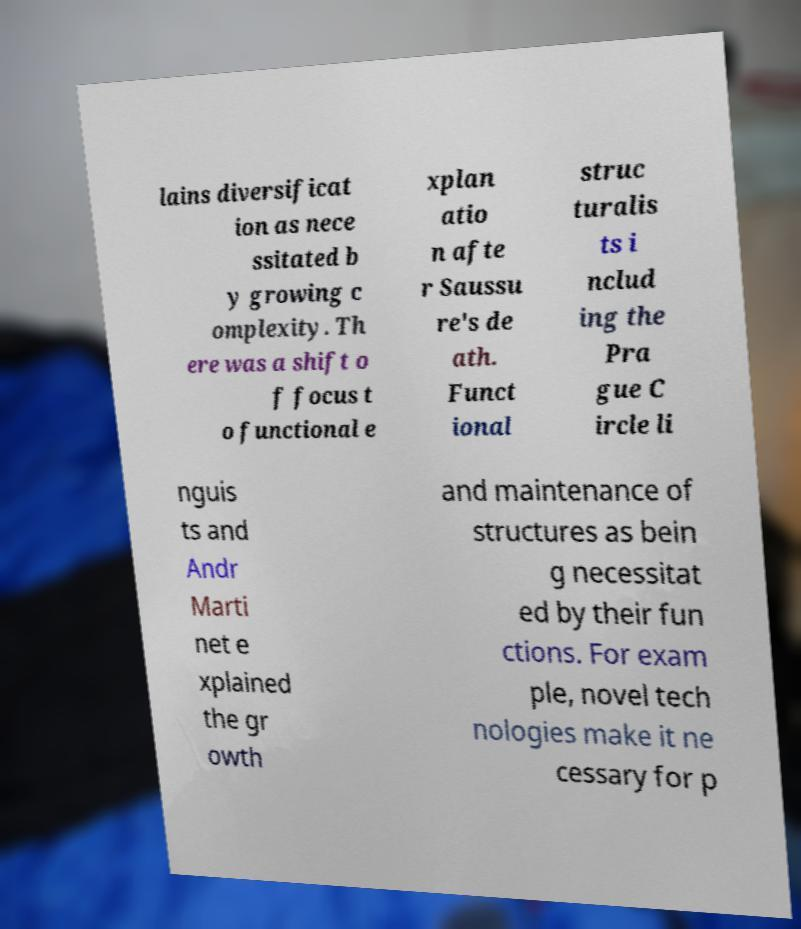Can you read and provide the text displayed in the image?This photo seems to have some interesting text. Can you extract and type it out for me? lains diversificat ion as nece ssitated b y growing c omplexity. Th ere was a shift o f focus t o functional e xplan atio n afte r Saussu re's de ath. Funct ional struc turalis ts i nclud ing the Pra gue C ircle li nguis ts and Andr Marti net e xplained the gr owth and maintenance of structures as bein g necessitat ed by their fun ctions. For exam ple, novel tech nologies make it ne cessary for p 